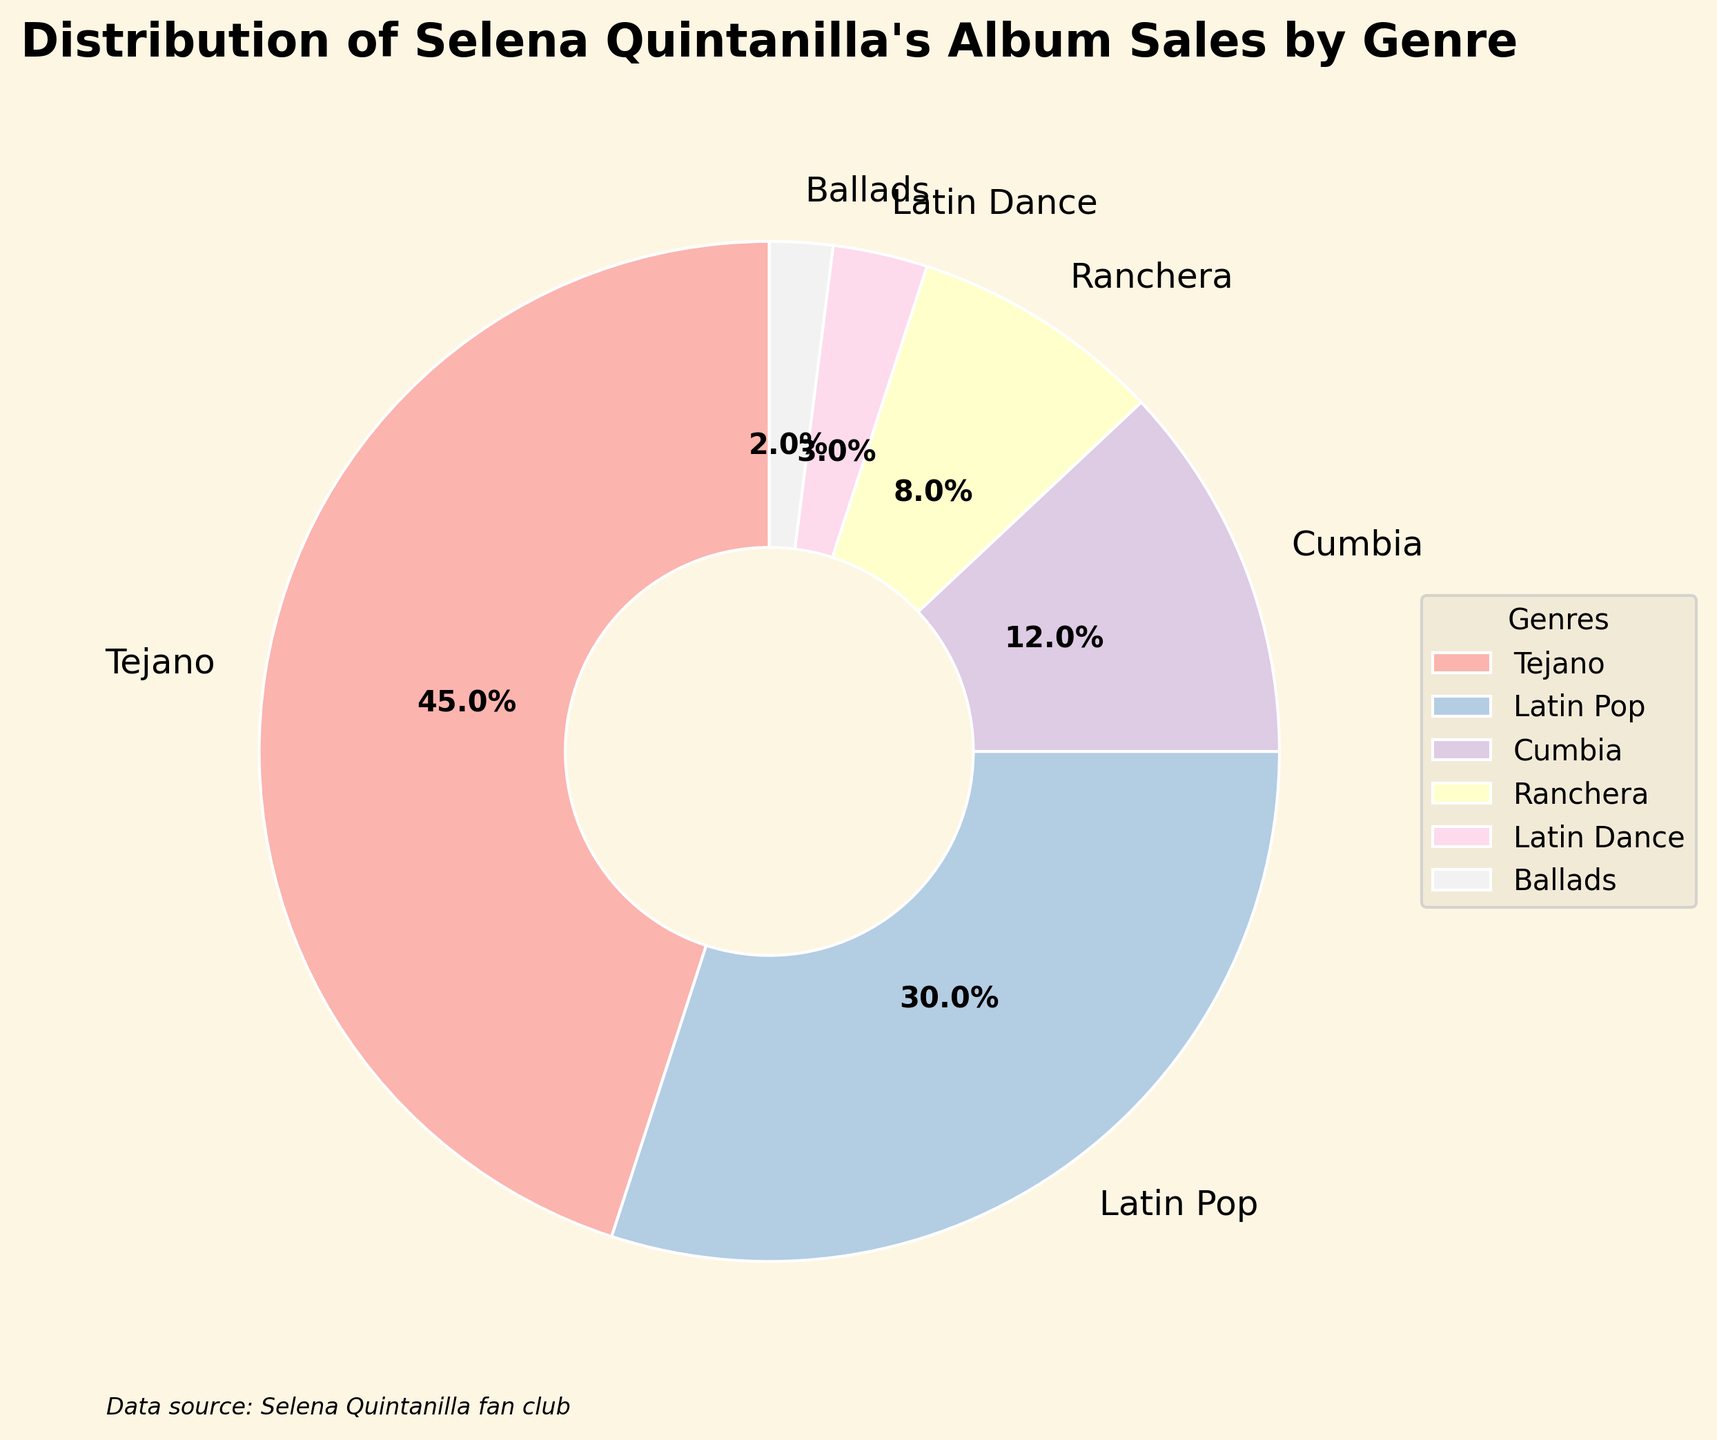What genre has the highest percentage of album sales? The pie chart shows that the "Tejano" genre has the largest slice, which represents the highest percentage.
Answer: Tejano Which genre has the lowest sales percentage? The smallest slice in the pie chart represents the "Ballads" genre.
Answer: Ballads What percentage of the total sales is represented by Latin genres (Latin Pop, Latin Dance)? Add the percentages of "Latin Pop" and "Latin Dance": 30% + 3% = 33%.
Answer: 33% How does the sales percentage of the Cumbia genre compare to the Ranchera genre? The sales percentage for Cumbia is 12%, while for Ranchera it is 8%. Cumbia has a higher percentage than Ranchera.
Answer: Cumbia has a higher percentage What is the combined sales percentage of Tejano and Cumbia genres? The sales percentage for Tejano is 45% and for Cumbia is 12%. Adding these together: 45% + 12% = 57%.
Answer: 57% Are there more album sales in the Ranchera or Latin Dance genres? The Ranchera genre has 8% of sales, whereas the Latin Dance genre has 3%. Thus, Ranchera has more sales.
Answer: Ranchera has more sales What percentage less is the sales percentage of Ranchera compared to Tejano? Subtract the percentage of Ranchera from Tejano: 45% - 8% = 37%.
Answer: 37% Which three genres have the largest sales percentages? The three largest slices represent Tejano (45%), Latin Pop (30%), and Cumbia (12%).
Answer: Tejano, Latin Pop, Cumbia How does the total sales percentage of Ballads and Latin Dance compare to Cumbia? Adding Ballads (2%) and Latin Dance (3%) gives a total of 5%. Since Cumbia has 12%, Cumbia has a higher percentage.
Answer: Cumbia is higher What colors represent Ranchera and Latin Dance genres in the pie chart? Observing the pie chart, we can see that Ranchera and Latin Dance are represented by different pastel colors.
Answer: Answer with color names identified in the plot 